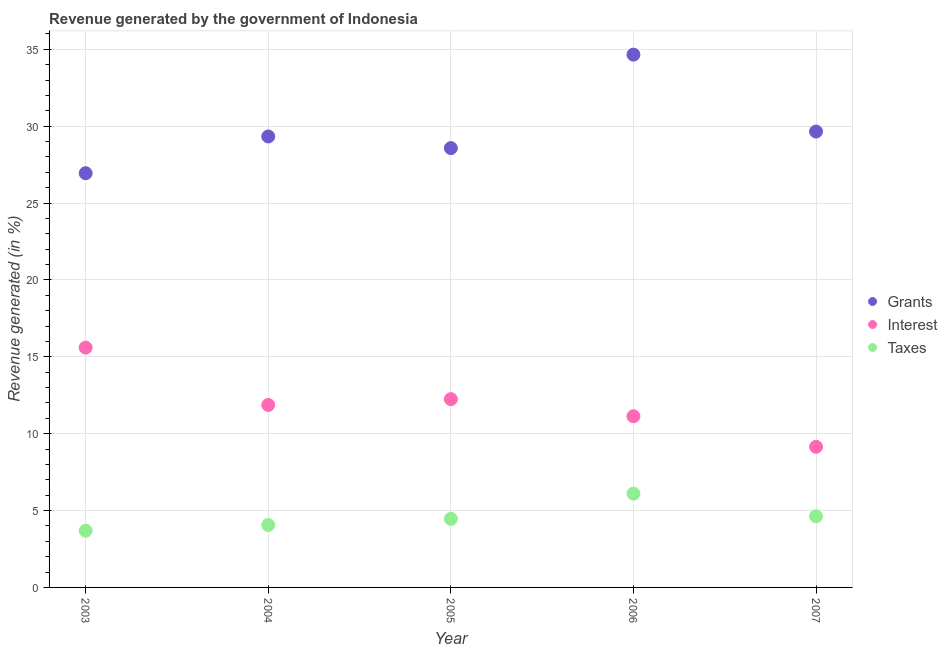How many different coloured dotlines are there?
Offer a very short reply. 3. Is the number of dotlines equal to the number of legend labels?
Make the answer very short. Yes. What is the percentage of revenue generated by interest in 2004?
Offer a terse response. 11.87. Across all years, what is the maximum percentage of revenue generated by grants?
Offer a terse response. 34.65. Across all years, what is the minimum percentage of revenue generated by interest?
Offer a terse response. 9.15. In which year was the percentage of revenue generated by grants maximum?
Offer a terse response. 2006. In which year was the percentage of revenue generated by interest minimum?
Offer a terse response. 2007. What is the total percentage of revenue generated by interest in the graph?
Your response must be concise. 60. What is the difference between the percentage of revenue generated by taxes in 2004 and that in 2006?
Provide a short and direct response. -2.04. What is the difference between the percentage of revenue generated by grants in 2003 and the percentage of revenue generated by taxes in 2005?
Make the answer very short. 22.48. What is the average percentage of revenue generated by grants per year?
Make the answer very short. 29.83. In the year 2007, what is the difference between the percentage of revenue generated by interest and percentage of revenue generated by grants?
Your answer should be very brief. -20.51. In how many years, is the percentage of revenue generated by interest greater than 25 %?
Offer a terse response. 0. What is the ratio of the percentage of revenue generated by interest in 2005 to that in 2006?
Provide a succinct answer. 1.1. Is the difference between the percentage of revenue generated by taxes in 2003 and 2004 greater than the difference between the percentage of revenue generated by grants in 2003 and 2004?
Your response must be concise. Yes. What is the difference between the highest and the second highest percentage of revenue generated by grants?
Give a very brief answer. 5. What is the difference between the highest and the lowest percentage of revenue generated by interest?
Provide a short and direct response. 6.45. Is the sum of the percentage of revenue generated by interest in 2004 and 2005 greater than the maximum percentage of revenue generated by grants across all years?
Provide a succinct answer. No. Does the percentage of revenue generated by grants monotonically increase over the years?
Your answer should be very brief. No. Is the percentage of revenue generated by taxes strictly greater than the percentage of revenue generated by grants over the years?
Ensure brevity in your answer.  No. How many dotlines are there?
Provide a succinct answer. 3. What is the difference between two consecutive major ticks on the Y-axis?
Provide a succinct answer. 5. Are the values on the major ticks of Y-axis written in scientific E-notation?
Ensure brevity in your answer.  No. Does the graph contain any zero values?
Offer a terse response. No. Does the graph contain grids?
Keep it short and to the point. Yes. Where does the legend appear in the graph?
Keep it short and to the point. Center right. How many legend labels are there?
Make the answer very short. 3. What is the title of the graph?
Keep it short and to the point. Revenue generated by the government of Indonesia. Does "Tertiary education" appear as one of the legend labels in the graph?
Offer a terse response. No. What is the label or title of the X-axis?
Your answer should be compact. Year. What is the label or title of the Y-axis?
Keep it short and to the point. Revenue generated (in %). What is the Revenue generated (in %) in Grants in 2003?
Provide a short and direct response. 26.94. What is the Revenue generated (in %) of Interest in 2003?
Ensure brevity in your answer.  15.6. What is the Revenue generated (in %) of Taxes in 2003?
Your answer should be very brief. 3.69. What is the Revenue generated (in %) in Grants in 2004?
Provide a succinct answer. 29.33. What is the Revenue generated (in %) in Interest in 2004?
Ensure brevity in your answer.  11.87. What is the Revenue generated (in %) of Taxes in 2004?
Ensure brevity in your answer.  4.06. What is the Revenue generated (in %) of Grants in 2005?
Provide a short and direct response. 28.57. What is the Revenue generated (in %) in Interest in 2005?
Your response must be concise. 12.25. What is the Revenue generated (in %) of Taxes in 2005?
Provide a succinct answer. 4.46. What is the Revenue generated (in %) in Grants in 2006?
Ensure brevity in your answer.  34.65. What is the Revenue generated (in %) of Interest in 2006?
Give a very brief answer. 11.14. What is the Revenue generated (in %) of Taxes in 2006?
Your response must be concise. 6.1. What is the Revenue generated (in %) of Grants in 2007?
Your answer should be very brief. 29.65. What is the Revenue generated (in %) of Interest in 2007?
Ensure brevity in your answer.  9.15. What is the Revenue generated (in %) in Taxes in 2007?
Your answer should be compact. 4.63. Across all years, what is the maximum Revenue generated (in %) in Grants?
Offer a terse response. 34.65. Across all years, what is the maximum Revenue generated (in %) in Interest?
Keep it short and to the point. 15.6. Across all years, what is the maximum Revenue generated (in %) of Taxes?
Keep it short and to the point. 6.1. Across all years, what is the minimum Revenue generated (in %) in Grants?
Give a very brief answer. 26.94. Across all years, what is the minimum Revenue generated (in %) in Interest?
Your answer should be very brief. 9.15. Across all years, what is the minimum Revenue generated (in %) in Taxes?
Make the answer very short. 3.69. What is the total Revenue generated (in %) of Grants in the graph?
Your answer should be compact. 149.15. What is the total Revenue generated (in %) in Interest in the graph?
Keep it short and to the point. 59.99. What is the total Revenue generated (in %) in Taxes in the graph?
Ensure brevity in your answer.  22.94. What is the difference between the Revenue generated (in %) in Grants in 2003 and that in 2004?
Your answer should be compact. -2.39. What is the difference between the Revenue generated (in %) of Interest in 2003 and that in 2004?
Keep it short and to the point. 3.73. What is the difference between the Revenue generated (in %) in Taxes in 2003 and that in 2004?
Give a very brief answer. -0.37. What is the difference between the Revenue generated (in %) in Grants in 2003 and that in 2005?
Give a very brief answer. -1.63. What is the difference between the Revenue generated (in %) of Interest in 2003 and that in 2005?
Your answer should be very brief. 3.35. What is the difference between the Revenue generated (in %) in Taxes in 2003 and that in 2005?
Your answer should be compact. -0.77. What is the difference between the Revenue generated (in %) of Grants in 2003 and that in 2006?
Keep it short and to the point. -7.71. What is the difference between the Revenue generated (in %) of Interest in 2003 and that in 2006?
Keep it short and to the point. 4.46. What is the difference between the Revenue generated (in %) in Taxes in 2003 and that in 2006?
Keep it short and to the point. -2.42. What is the difference between the Revenue generated (in %) of Grants in 2003 and that in 2007?
Make the answer very short. -2.71. What is the difference between the Revenue generated (in %) in Interest in 2003 and that in 2007?
Your answer should be compact. 6.45. What is the difference between the Revenue generated (in %) in Taxes in 2003 and that in 2007?
Your answer should be compact. -0.94. What is the difference between the Revenue generated (in %) of Grants in 2004 and that in 2005?
Ensure brevity in your answer.  0.76. What is the difference between the Revenue generated (in %) in Interest in 2004 and that in 2005?
Ensure brevity in your answer.  -0.38. What is the difference between the Revenue generated (in %) in Taxes in 2004 and that in 2005?
Give a very brief answer. -0.4. What is the difference between the Revenue generated (in %) in Grants in 2004 and that in 2006?
Provide a short and direct response. -5.32. What is the difference between the Revenue generated (in %) in Interest in 2004 and that in 2006?
Your answer should be compact. 0.73. What is the difference between the Revenue generated (in %) of Taxes in 2004 and that in 2006?
Give a very brief answer. -2.04. What is the difference between the Revenue generated (in %) of Grants in 2004 and that in 2007?
Your answer should be compact. -0.32. What is the difference between the Revenue generated (in %) in Interest in 2004 and that in 2007?
Keep it short and to the point. 2.72. What is the difference between the Revenue generated (in %) of Taxes in 2004 and that in 2007?
Keep it short and to the point. -0.57. What is the difference between the Revenue generated (in %) in Grants in 2005 and that in 2006?
Provide a short and direct response. -6.08. What is the difference between the Revenue generated (in %) in Interest in 2005 and that in 2006?
Your response must be concise. 1.11. What is the difference between the Revenue generated (in %) of Taxes in 2005 and that in 2006?
Make the answer very short. -1.64. What is the difference between the Revenue generated (in %) of Grants in 2005 and that in 2007?
Offer a very short reply. -1.08. What is the difference between the Revenue generated (in %) in Interest in 2005 and that in 2007?
Provide a succinct answer. 3.1. What is the difference between the Revenue generated (in %) of Taxes in 2005 and that in 2007?
Provide a succinct answer. -0.17. What is the difference between the Revenue generated (in %) of Grants in 2006 and that in 2007?
Your answer should be compact. 5. What is the difference between the Revenue generated (in %) in Interest in 2006 and that in 2007?
Provide a short and direct response. 1.99. What is the difference between the Revenue generated (in %) of Taxes in 2006 and that in 2007?
Offer a terse response. 1.47. What is the difference between the Revenue generated (in %) of Grants in 2003 and the Revenue generated (in %) of Interest in 2004?
Offer a very short reply. 15.07. What is the difference between the Revenue generated (in %) in Grants in 2003 and the Revenue generated (in %) in Taxes in 2004?
Offer a terse response. 22.88. What is the difference between the Revenue generated (in %) of Interest in 2003 and the Revenue generated (in %) of Taxes in 2004?
Keep it short and to the point. 11.54. What is the difference between the Revenue generated (in %) of Grants in 2003 and the Revenue generated (in %) of Interest in 2005?
Your answer should be compact. 14.7. What is the difference between the Revenue generated (in %) in Grants in 2003 and the Revenue generated (in %) in Taxes in 2005?
Give a very brief answer. 22.48. What is the difference between the Revenue generated (in %) of Interest in 2003 and the Revenue generated (in %) of Taxes in 2005?
Offer a very short reply. 11.14. What is the difference between the Revenue generated (in %) in Grants in 2003 and the Revenue generated (in %) in Interest in 2006?
Provide a short and direct response. 15.81. What is the difference between the Revenue generated (in %) in Grants in 2003 and the Revenue generated (in %) in Taxes in 2006?
Offer a terse response. 20.84. What is the difference between the Revenue generated (in %) in Interest in 2003 and the Revenue generated (in %) in Taxes in 2006?
Provide a short and direct response. 9.5. What is the difference between the Revenue generated (in %) of Grants in 2003 and the Revenue generated (in %) of Interest in 2007?
Your answer should be very brief. 17.8. What is the difference between the Revenue generated (in %) of Grants in 2003 and the Revenue generated (in %) of Taxes in 2007?
Make the answer very short. 22.31. What is the difference between the Revenue generated (in %) of Interest in 2003 and the Revenue generated (in %) of Taxes in 2007?
Give a very brief answer. 10.97. What is the difference between the Revenue generated (in %) of Grants in 2004 and the Revenue generated (in %) of Interest in 2005?
Your answer should be compact. 17.08. What is the difference between the Revenue generated (in %) in Grants in 2004 and the Revenue generated (in %) in Taxes in 2005?
Keep it short and to the point. 24.87. What is the difference between the Revenue generated (in %) of Interest in 2004 and the Revenue generated (in %) of Taxes in 2005?
Make the answer very short. 7.41. What is the difference between the Revenue generated (in %) of Grants in 2004 and the Revenue generated (in %) of Interest in 2006?
Keep it short and to the point. 18.19. What is the difference between the Revenue generated (in %) in Grants in 2004 and the Revenue generated (in %) in Taxes in 2006?
Your answer should be very brief. 23.23. What is the difference between the Revenue generated (in %) of Interest in 2004 and the Revenue generated (in %) of Taxes in 2006?
Provide a short and direct response. 5.77. What is the difference between the Revenue generated (in %) in Grants in 2004 and the Revenue generated (in %) in Interest in 2007?
Your answer should be very brief. 20.18. What is the difference between the Revenue generated (in %) of Grants in 2004 and the Revenue generated (in %) of Taxes in 2007?
Your answer should be very brief. 24.7. What is the difference between the Revenue generated (in %) of Interest in 2004 and the Revenue generated (in %) of Taxes in 2007?
Provide a short and direct response. 7.24. What is the difference between the Revenue generated (in %) of Grants in 2005 and the Revenue generated (in %) of Interest in 2006?
Offer a terse response. 17.44. What is the difference between the Revenue generated (in %) of Grants in 2005 and the Revenue generated (in %) of Taxes in 2006?
Give a very brief answer. 22.47. What is the difference between the Revenue generated (in %) of Interest in 2005 and the Revenue generated (in %) of Taxes in 2006?
Your answer should be compact. 6.14. What is the difference between the Revenue generated (in %) in Grants in 2005 and the Revenue generated (in %) in Interest in 2007?
Ensure brevity in your answer.  19.43. What is the difference between the Revenue generated (in %) in Grants in 2005 and the Revenue generated (in %) in Taxes in 2007?
Keep it short and to the point. 23.95. What is the difference between the Revenue generated (in %) in Interest in 2005 and the Revenue generated (in %) in Taxes in 2007?
Keep it short and to the point. 7.62. What is the difference between the Revenue generated (in %) of Grants in 2006 and the Revenue generated (in %) of Interest in 2007?
Keep it short and to the point. 25.51. What is the difference between the Revenue generated (in %) in Grants in 2006 and the Revenue generated (in %) in Taxes in 2007?
Provide a short and direct response. 30.03. What is the difference between the Revenue generated (in %) of Interest in 2006 and the Revenue generated (in %) of Taxes in 2007?
Make the answer very short. 6.51. What is the average Revenue generated (in %) in Grants per year?
Give a very brief answer. 29.83. What is the average Revenue generated (in %) of Interest per year?
Offer a terse response. 12. What is the average Revenue generated (in %) in Taxes per year?
Give a very brief answer. 4.59. In the year 2003, what is the difference between the Revenue generated (in %) of Grants and Revenue generated (in %) of Interest?
Ensure brevity in your answer.  11.34. In the year 2003, what is the difference between the Revenue generated (in %) of Grants and Revenue generated (in %) of Taxes?
Your response must be concise. 23.25. In the year 2003, what is the difference between the Revenue generated (in %) in Interest and Revenue generated (in %) in Taxes?
Give a very brief answer. 11.91. In the year 2004, what is the difference between the Revenue generated (in %) of Grants and Revenue generated (in %) of Interest?
Your answer should be very brief. 17.46. In the year 2004, what is the difference between the Revenue generated (in %) in Grants and Revenue generated (in %) in Taxes?
Offer a very short reply. 25.27. In the year 2004, what is the difference between the Revenue generated (in %) in Interest and Revenue generated (in %) in Taxes?
Provide a succinct answer. 7.81. In the year 2005, what is the difference between the Revenue generated (in %) of Grants and Revenue generated (in %) of Interest?
Give a very brief answer. 16.33. In the year 2005, what is the difference between the Revenue generated (in %) in Grants and Revenue generated (in %) in Taxes?
Offer a terse response. 24.11. In the year 2005, what is the difference between the Revenue generated (in %) of Interest and Revenue generated (in %) of Taxes?
Provide a succinct answer. 7.78. In the year 2006, what is the difference between the Revenue generated (in %) in Grants and Revenue generated (in %) in Interest?
Your answer should be compact. 23.52. In the year 2006, what is the difference between the Revenue generated (in %) of Grants and Revenue generated (in %) of Taxes?
Give a very brief answer. 28.55. In the year 2006, what is the difference between the Revenue generated (in %) in Interest and Revenue generated (in %) in Taxes?
Provide a succinct answer. 5.03. In the year 2007, what is the difference between the Revenue generated (in %) of Grants and Revenue generated (in %) of Interest?
Keep it short and to the point. 20.51. In the year 2007, what is the difference between the Revenue generated (in %) in Grants and Revenue generated (in %) in Taxes?
Give a very brief answer. 25.02. In the year 2007, what is the difference between the Revenue generated (in %) of Interest and Revenue generated (in %) of Taxes?
Your answer should be very brief. 4.52. What is the ratio of the Revenue generated (in %) of Grants in 2003 to that in 2004?
Offer a very short reply. 0.92. What is the ratio of the Revenue generated (in %) of Interest in 2003 to that in 2004?
Ensure brevity in your answer.  1.31. What is the ratio of the Revenue generated (in %) of Taxes in 2003 to that in 2004?
Provide a short and direct response. 0.91. What is the ratio of the Revenue generated (in %) of Grants in 2003 to that in 2005?
Give a very brief answer. 0.94. What is the ratio of the Revenue generated (in %) of Interest in 2003 to that in 2005?
Provide a succinct answer. 1.27. What is the ratio of the Revenue generated (in %) of Taxes in 2003 to that in 2005?
Your answer should be very brief. 0.83. What is the ratio of the Revenue generated (in %) of Grants in 2003 to that in 2006?
Make the answer very short. 0.78. What is the ratio of the Revenue generated (in %) in Interest in 2003 to that in 2006?
Your response must be concise. 1.4. What is the ratio of the Revenue generated (in %) in Taxes in 2003 to that in 2006?
Give a very brief answer. 0.6. What is the ratio of the Revenue generated (in %) of Grants in 2003 to that in 2007?
Provide a short and direct response. 0.91. What is the ratio of the Revenue generated (in %) in Interest in 2003 to that in 2007?
Make the answer very short. 1.71. What is the ratio of the Revenue generated (in %) of Taxes in 2003 to that in 2007?
Your answer should be compact. 0.8. What is the ratio of the Revenue generated (in %) of Grants in 2004 to that in 2005?
Your answer should be very brief. 1.03. What is the ratio of the Revenue generated (in %) in Interest in 2004 to that in 2005?
Offer a terse response. 0.97. What is the ratio of the Revenue generated (in %) of Taxes in 2004 to that in 2005?
Offer a very short reply. 0.91. What is the ratio of the Revenue generated (in %) in Grants in 2004 to that in 2006?
Your answer should be very brief. 0.85. What is the ratio of the Revenue generated (in %) of Interest in 2004 to that in 2006?
Give a very brief answer. 1.07. What is the ratio of the Revenue generated (in %) of Taxes in 2004 to that in 2006?
Provide a short and direct response. 0.67. What is the ratio of the Revenue generated (in %) of Grants in 2004 to that in 2007?
Your response must be concise. 0.99. What is the ratio of the Revenue generated (in %) of Interest in 2004 to that in 2007?
Your answer should be compact. 1.3. What is the ratio of the Revenue generated (in %) of Taxes in 2004 to that in 2007?
Your response must be concise. 0.88. What is the ratio of the Revenue generated (in %) of Grants in 2005 to that in 2006?
Your answer should be very brief. 0.82. What is the ratio of the Revenue generated (in %) of Interest in 2005 to that in 2006?
Ensure brevity in your answer.  1.1. What is the ratio of the Revenue generated (in %) in Taxes in 2005 to that in 2006?
Offer a very short reply. 0.73. What is the ratio of the Revenue generated (in %) in Grants in 2005 to that in 2007?
Your answer should be very brief. 0.96. What is the ratio of the Revenue generated (in %) of Interest in 2005 to that in 2007?
Your answer should be compact. 1.34. What is the ratio of the Revenue generated (in %) of Taxes in 2005 to that in 2007?
Provide a succinct answer. 0.96. What is the ratio of the Revenue generated (in %) of Grants in 2006 to that in 2007?
Offer a terse response. 1.17. What is the ratio of the Revenue generated (in %) in Interest in 2006 to that in 2007?
Your answer should be compact. 1.22. What is the ratio of the Revenue generated (in %) in Taxes in 2006 to that in 2007?
Make the answer very short. 1.32. What is the difference between the highest and the second highest Revenue generated (in %) in Grants?
Provide a short and direct response. 5. What is the difference between the highest and the second highest Revenue generated (in %) in Interest?
Your response must be concise. 3.35. What is the difference between the highest and the second highest Revenue generated (in %) in Taxes?
Your answer should be compact. 1.47. What is the difference between the highest and the lowest Revenue generated (in %) in Grants?
Your answer should be compact. 7.71. What is the difference between the highest and the lowest Revenue generated (in %) of Interest?
Your answer should be very brief. 6.45. What is the difference between the highest and the lowest Revenue generated (in %) in Taxes?
Your answer should be compact. 2.42. 